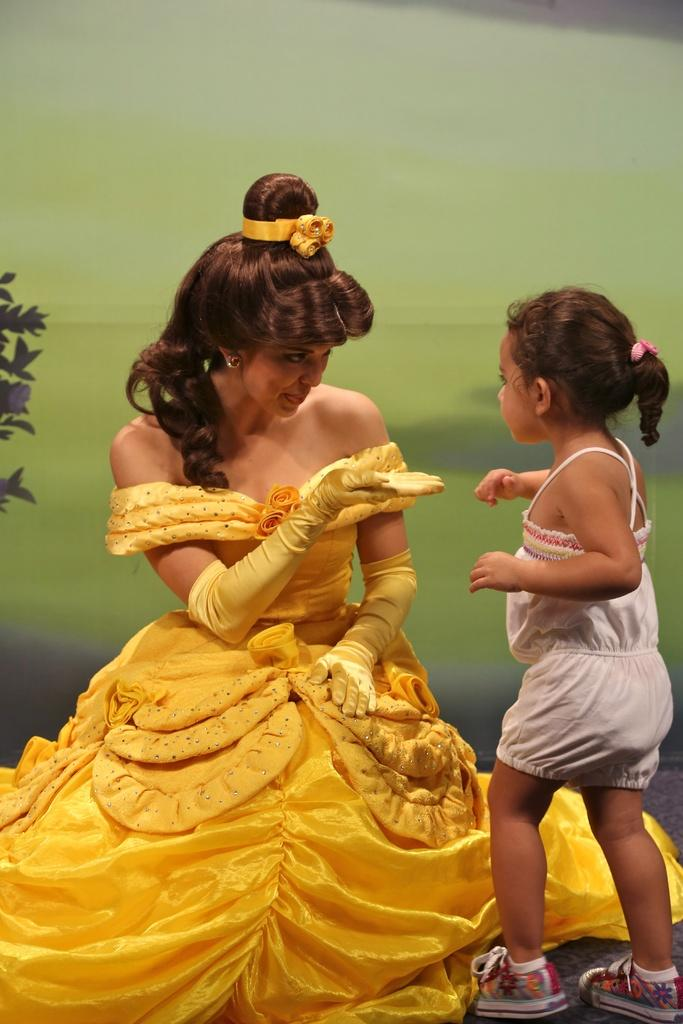How many people are in the image? There are two people in the image. What colors are the dresses of the people in the image? One person is wearing a white dress, and the other person is wearing a yellow dress. What can be seen to the left of the image? There is a plant visible to the left of the image. What colors are present in the background of the image? The background of the image includes a green and grey color surface. What theory is being discussed by the people in the image? There is no indication in the image that a theory is being discussed; the focus is on the people and their clothing colors, the plant, and the background colors. 